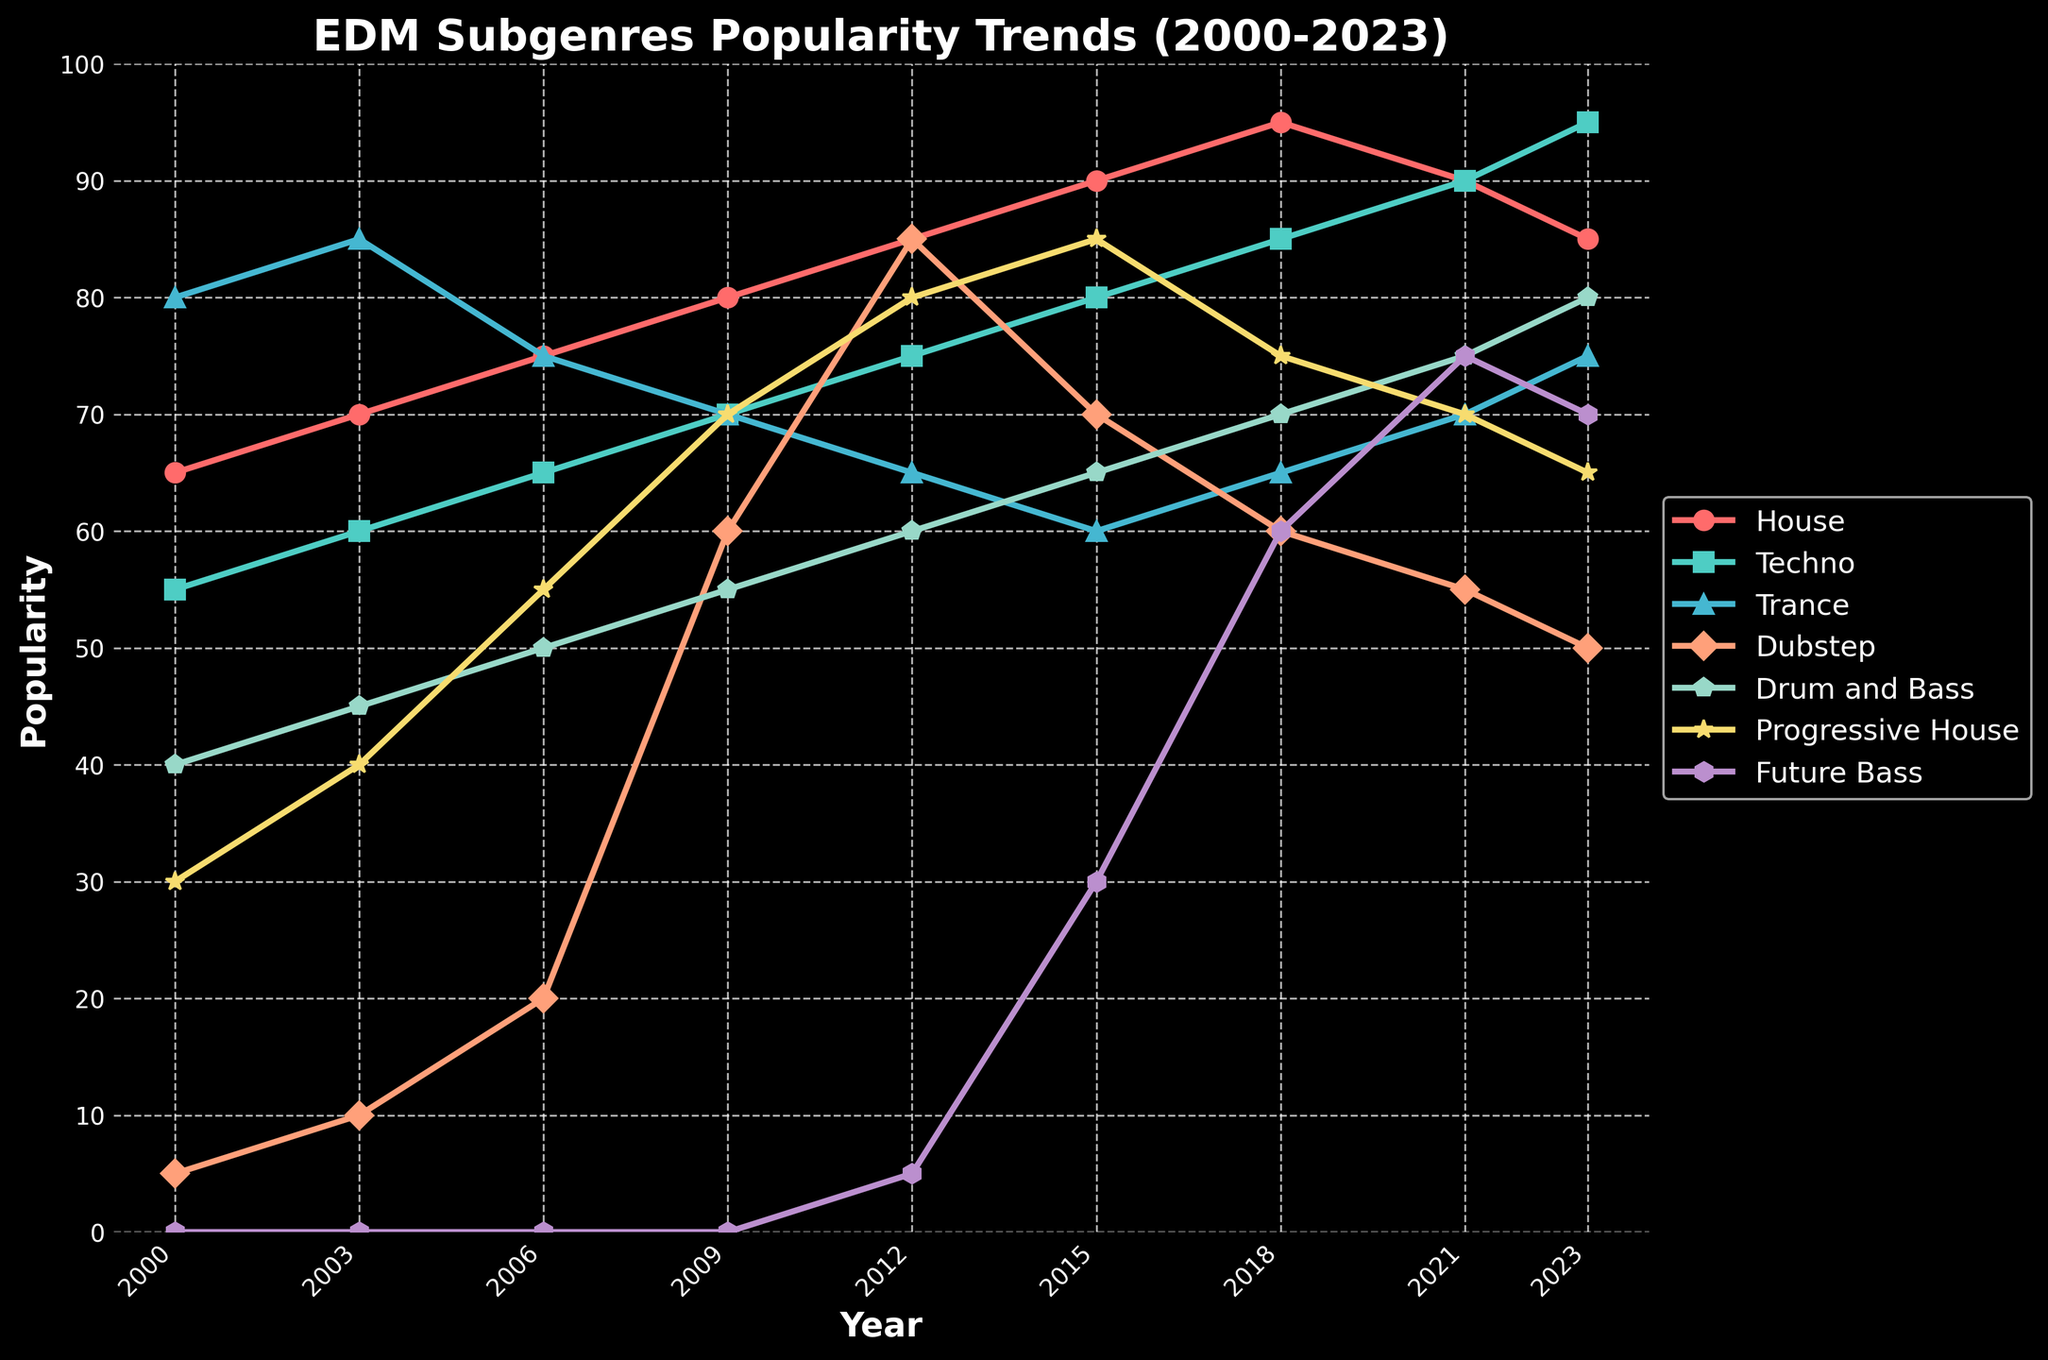Which subgenre was the most popular in 2000? In 2000, the subgenres' popularity values are displayed using markers on the lines. The highest value in 2000 is for Trance, which is at 80.
Answer: Trance How has the popularity of House changed from 2000 to 2023? By checking the House line from 2000 to 2023, you can see it starts at 65 in 2000 and ends at 85 in 2023. The popularity increased over the period.
Answer: Increased Which subgenre shows the largest increase in popularity from 2000 to 2023? By comparing the change in popularity for all subgenres from 2000 to 2023: House (65 to 85), Techno (55 to 95), Trance (80 to 75), Dubstep (5 to 50), Drum and Bass (40 to 80), Progressive House (30 to 65), and Future Bass (0 to 70). Techno has the largest increase (95 - 55 = 40).
Answer: Techno What is the average popularity of Techno between 2000 and 2023? The popularity values for Techno are 55, 60, 65, 70, 75, 80, 85, 90, 95. Adding these gives 675, and dividing by 9 gives 75.
Answer: 75 In which year did Dubstep experience its peak popularity? By observing the Dubstep line, its peak popularity of 85 occurred in 2012.
Answer: 2012 Which subgenre had the lowest popularity in 2015? In 2015, the popularity values are House (90), Techno (80), Trance (60), Dubstep (70), Drum and Bass (65), Progressive House (85), Future Bass (30). The lowest value is Future Bass at 30.
Answer: Future Bass Compare the popularity trends of Drum and Bass and Progressive House from 2009 to 2023. For Drum and Bass: 55 (2009) to 80 (2023), and for Progressive House: 70 (2009) to 65 (2023). Drum and Bass increased, while Progressive House shows a decrease.
Answer: Drum and Bass increased, Progressive House decreased What is the difference in popularity between House and Future Bass in 2018? In 2018, House has a popularity of 95 and Future Bass has 60. The difference is 95 - 60 = 35.
Answer: 35 Which year did Progressive House surpass the 80 popularity mark? The Progressive House line surpasses 80 in 2012 and reaches 85 in 2015.
Answer: 2012 From 2006 to 2009, which subgenre had the highest percentage increase in popularity? Percentage increase for each subgenre: House (75 to 80, 6.67%), Techno (65 to 70, 7.69%), Trance (75 to 70, -6.67%), Dubstep (20 to 60, 200%), Drum and Bass (50 to 55, 10%), Progressive House (55 to 70, 27.27%). Dubstep shows the highest percentage increase.
Answer: Dubstep 